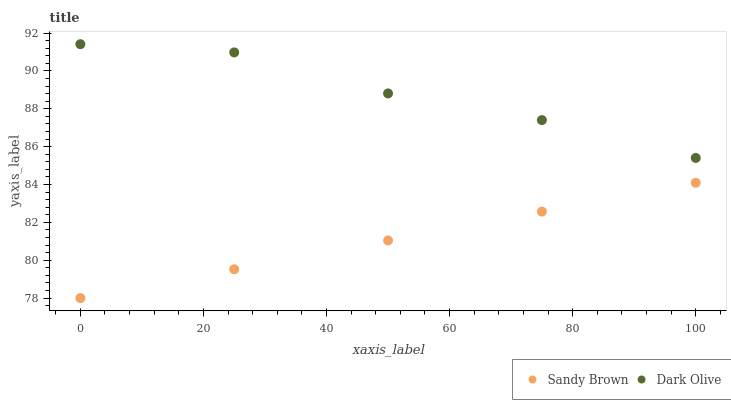Does Sandy Brown have the minimum area under the curve?
Answer yes or no. Yes. Does Dark Olive have the maximum area under the curve?
Answer yes or no. Yes. Does Sandy Brown have the maximum area under the curve?
Answer yes or no. No. Is Sandy Brown the smoothest?
Answer yes or no. Yes. Is Dark Olive the roughest?
Answer yes or no. Yes. Is Sandy Brown the roughest?
Answer yes or no. No. Does Sandy Brown have the lowest value?
Answer yes or no. Yes. Does Dark Olive have the highest value?
Answer yes or no. Yes. Does Sandy Brown have the highest value?
Answer yes or no. No. Is Sandy Brown less than Dark Olive?
Answer yes or no. Yes. Is Dark Olive greater than Sandy Brown?
Answer yes or no. Yes. Does Sandy Brown intersect Dark Olive?
Answer yes or no. No. 